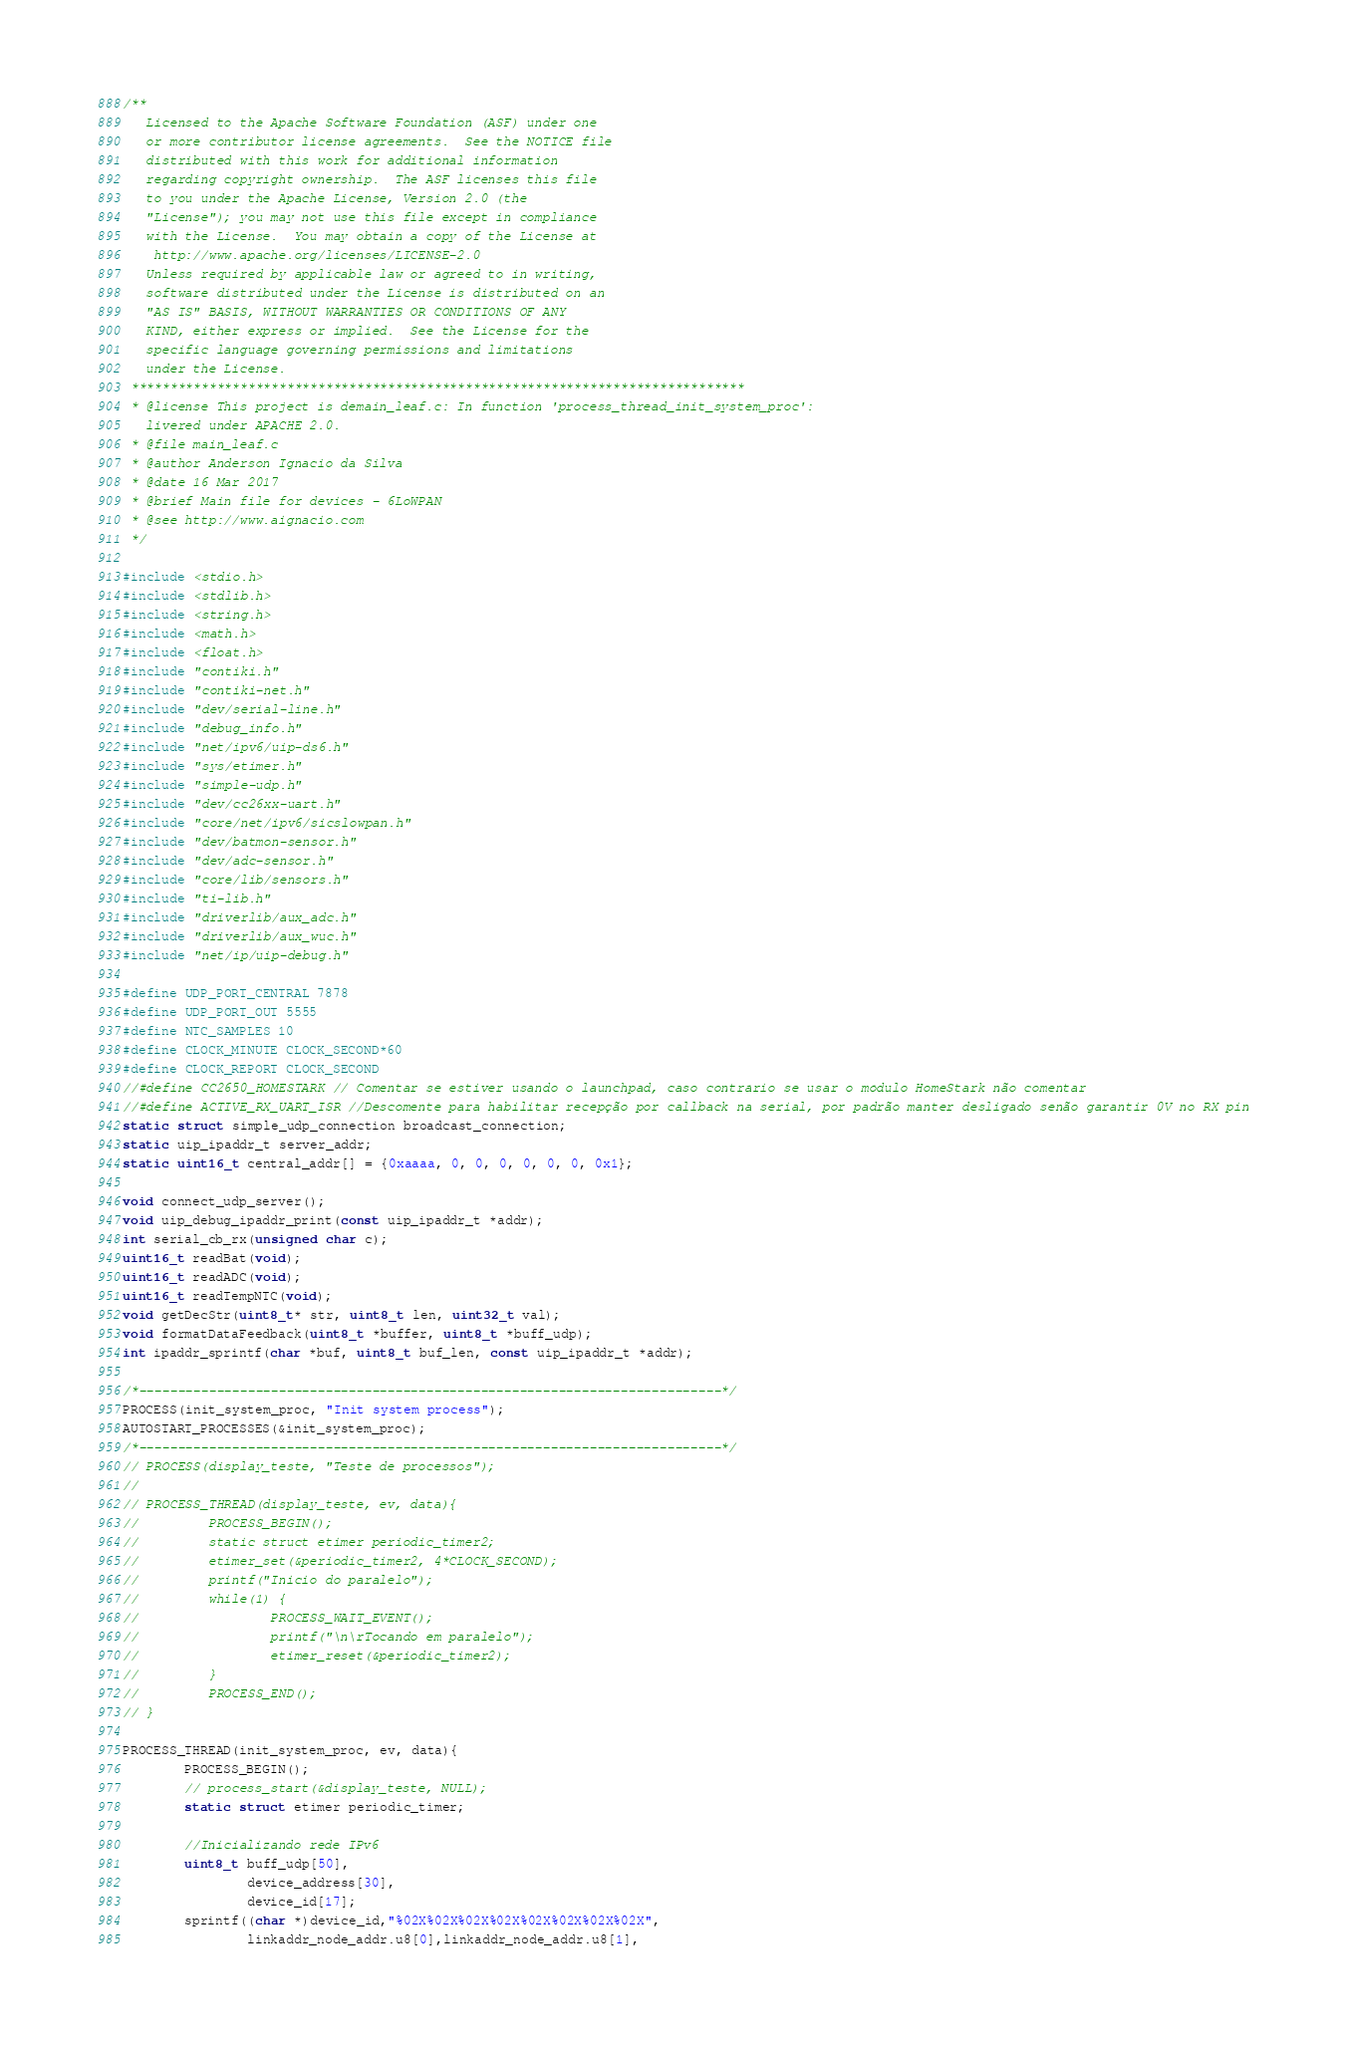<code> <loc_0><loc_0><loc_500><loc_500><_C_>/**
   Licensed to the Apache Software Foundation (ASF) under one
   or more contributor license agreements.  See the NOTICE file
   distributed with this work for additional information
   regarding copyright ownership.  The ASF licenses this file
   to you under the Apache License, Version 2.0 (the
   "License"); you may not use this file except in compliance
   with the License.  You may obtain a copy of the License at
    http://www.apache.org/licenses/LICENSE-2.0
   Unless required by applicable law or agreed to in writing,
   software distributed under the License is distributed on an
   "AS IS" BASIS, WITHOUT WARRANTIES OR CONDITIONS OF ANY
   KIND, either express or implied.  See the License for the
   specific language governing permissions and limitations
   under the License.
 *******************************************************************************
 * @license This project is demain_leaf.c: In function 'process_thread_init_system_proc':
   livered under APACHE 2.0.
 * @file main_leaf.c
 * @author Ânderson Ignacio da Silva
 * @date 16 Mar 2017
 * @brief Main file for devices - 6LoWPAN
 * @see http://www.aignacio.com
 */

#include <stdio.h>
#include <stdlib.h>
#include <string.h>
#include <math.h>
#include <float.h>
#include "contiki.h"
#include "contiki-net.h"
#include "dev/serial-line.h"
#include "debug_info.h"
#include "net/ipv6/uip-ds6.h"
#include "sys/etimer.h"
#include "simple-udp.h"
#include "dev/cc26xx-uart.h"
#include "core/net/ipv6/sicslowpan.h"
#include "dev/batmon-sensor.h"
#include "dev/adc-sensor.h"
#include "core/lib/sensors.h"
#include "ti-lib.h"
#include "driverlib/aux_adc.h"
#include "driverlib/aux_wuc.h"
#include "net/ip/uip-debug.h"

#define UDP_PORT_CENTRAL 7878
#define UDP_PORT_OUT 5555
#define NTC_SAMPLES 10
#define CLOCK_MINUTE CLOCK_SECOND*60
#define CLOCK_REPORT CLOCK_SECOND
//#define CC2650_HOMESTARK // Comentar se estiver usando o launchpad, caso contrário se usar o módulo HomeStark não comentar
//#define ACTIVE_RX_UART_ISR //Descomente para habilitar recepção por callback na serial, por padrão manter desligado senão garantir 0V no RX pin
static struct simple_udp_connection broadcast_connection;
static uip_ipaddr_t server_addr;
static uint16_t central_addr[] = {0xaaaa, 0, 0, 0, 0, 0, 0, 0x1};

void connect_udp_server();
void uip_debug_ipaddr_print(const uip_ipaddr_t *addr);
int serial_cb_rx(unsigned char c);
uint16_t readBat(void);
uint16_t readADC(void);
uint16_t readTempNTC(void);
void getDecStr(uint8_t* str, uint8_t len, uint32_t val);
void formatDataFeedback(uint8_t *buffer, uint8_t *buff_udp);
int ipaddr_sprintf(char *buf, uint8_t buf_len, const uip_ipaddr_t *addr);

/*---------------------------------------------------------------------------*/
PROCESS(init_system_proc, "Init system process");
AUTOSTART_PROCESSES(&init_system_proc);
/*---------------------------------------------------------------------------*/
// PROCESS(display_teste, "Teste de processos");
//
// PROCESS_THREAD(display_teste, ev, data){
//         PROCESS_BEGIN();
//         static struct etimer periodic_timer2;
//         etimer_set(&periodic_timer2, 4*CLOCK_SECOND);
//         printf("Inicio do paralelo");
//         while(1) {
//                 PROCESS_WAIT_EVENT();
//                 printf("\n\rTocando em paralelo");
//                 etimer_reset(&periodic_timer2);
//         }
//         PROCESS_END();
// }

PROCESS_THREAD(init_system_proc, ev, data){
        PROCESS_BEGIN();
        // process_start(&display_teste, NULL);
        static struct etimer periodic_timer;

        //Inicializando rede IPv6
        uint8_t buff_udp[50],
                device_address[30],
                device_id[17];
        sprintf((char *)device_id,"%02X%02X%02X%02X%02X%02X%02X%02X",
                linkaddr_node_addr.u8[0],linkaddr_node_addr.u8[1],</code> 